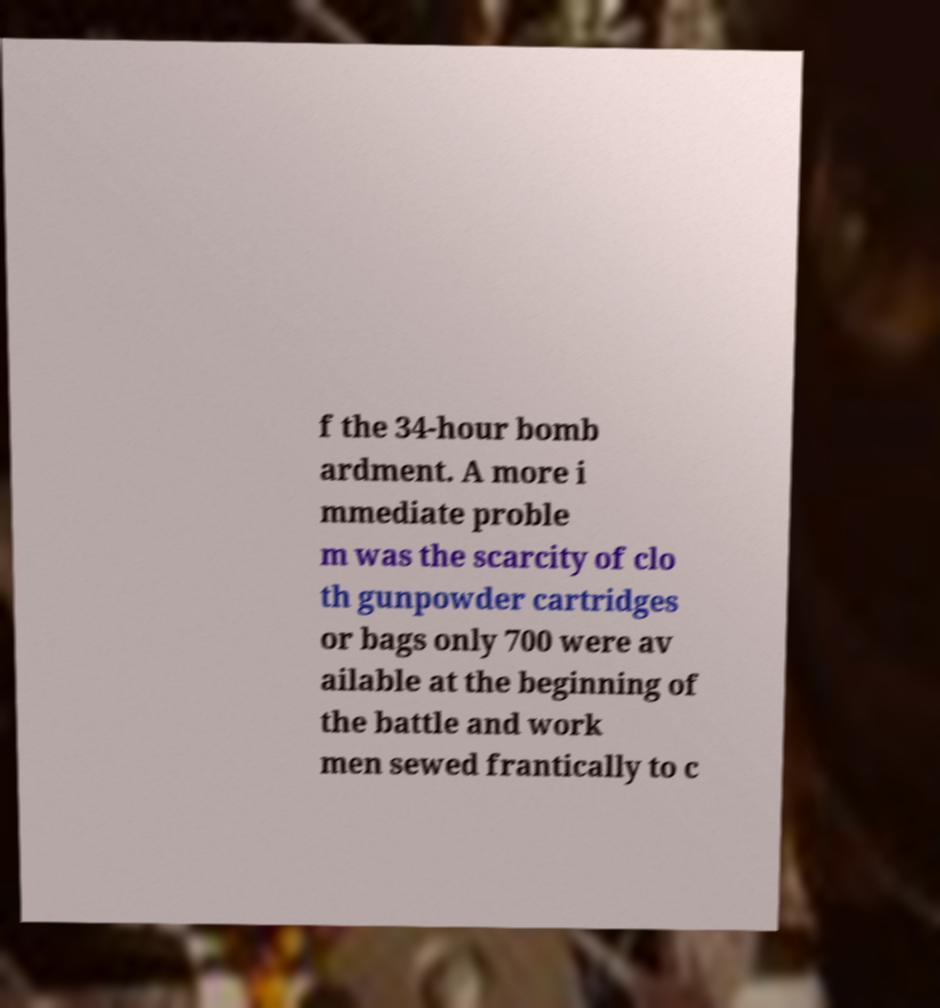What messages or text are displayed in this image? I need them in a readable, typed format. f the 34-hour bomb ardment. A more i mmediate proble m was the scarcity of clo th gunpowder cartridges or bags only 700 were av ailable at the beginning of the battle and work men sewed frantically to c 